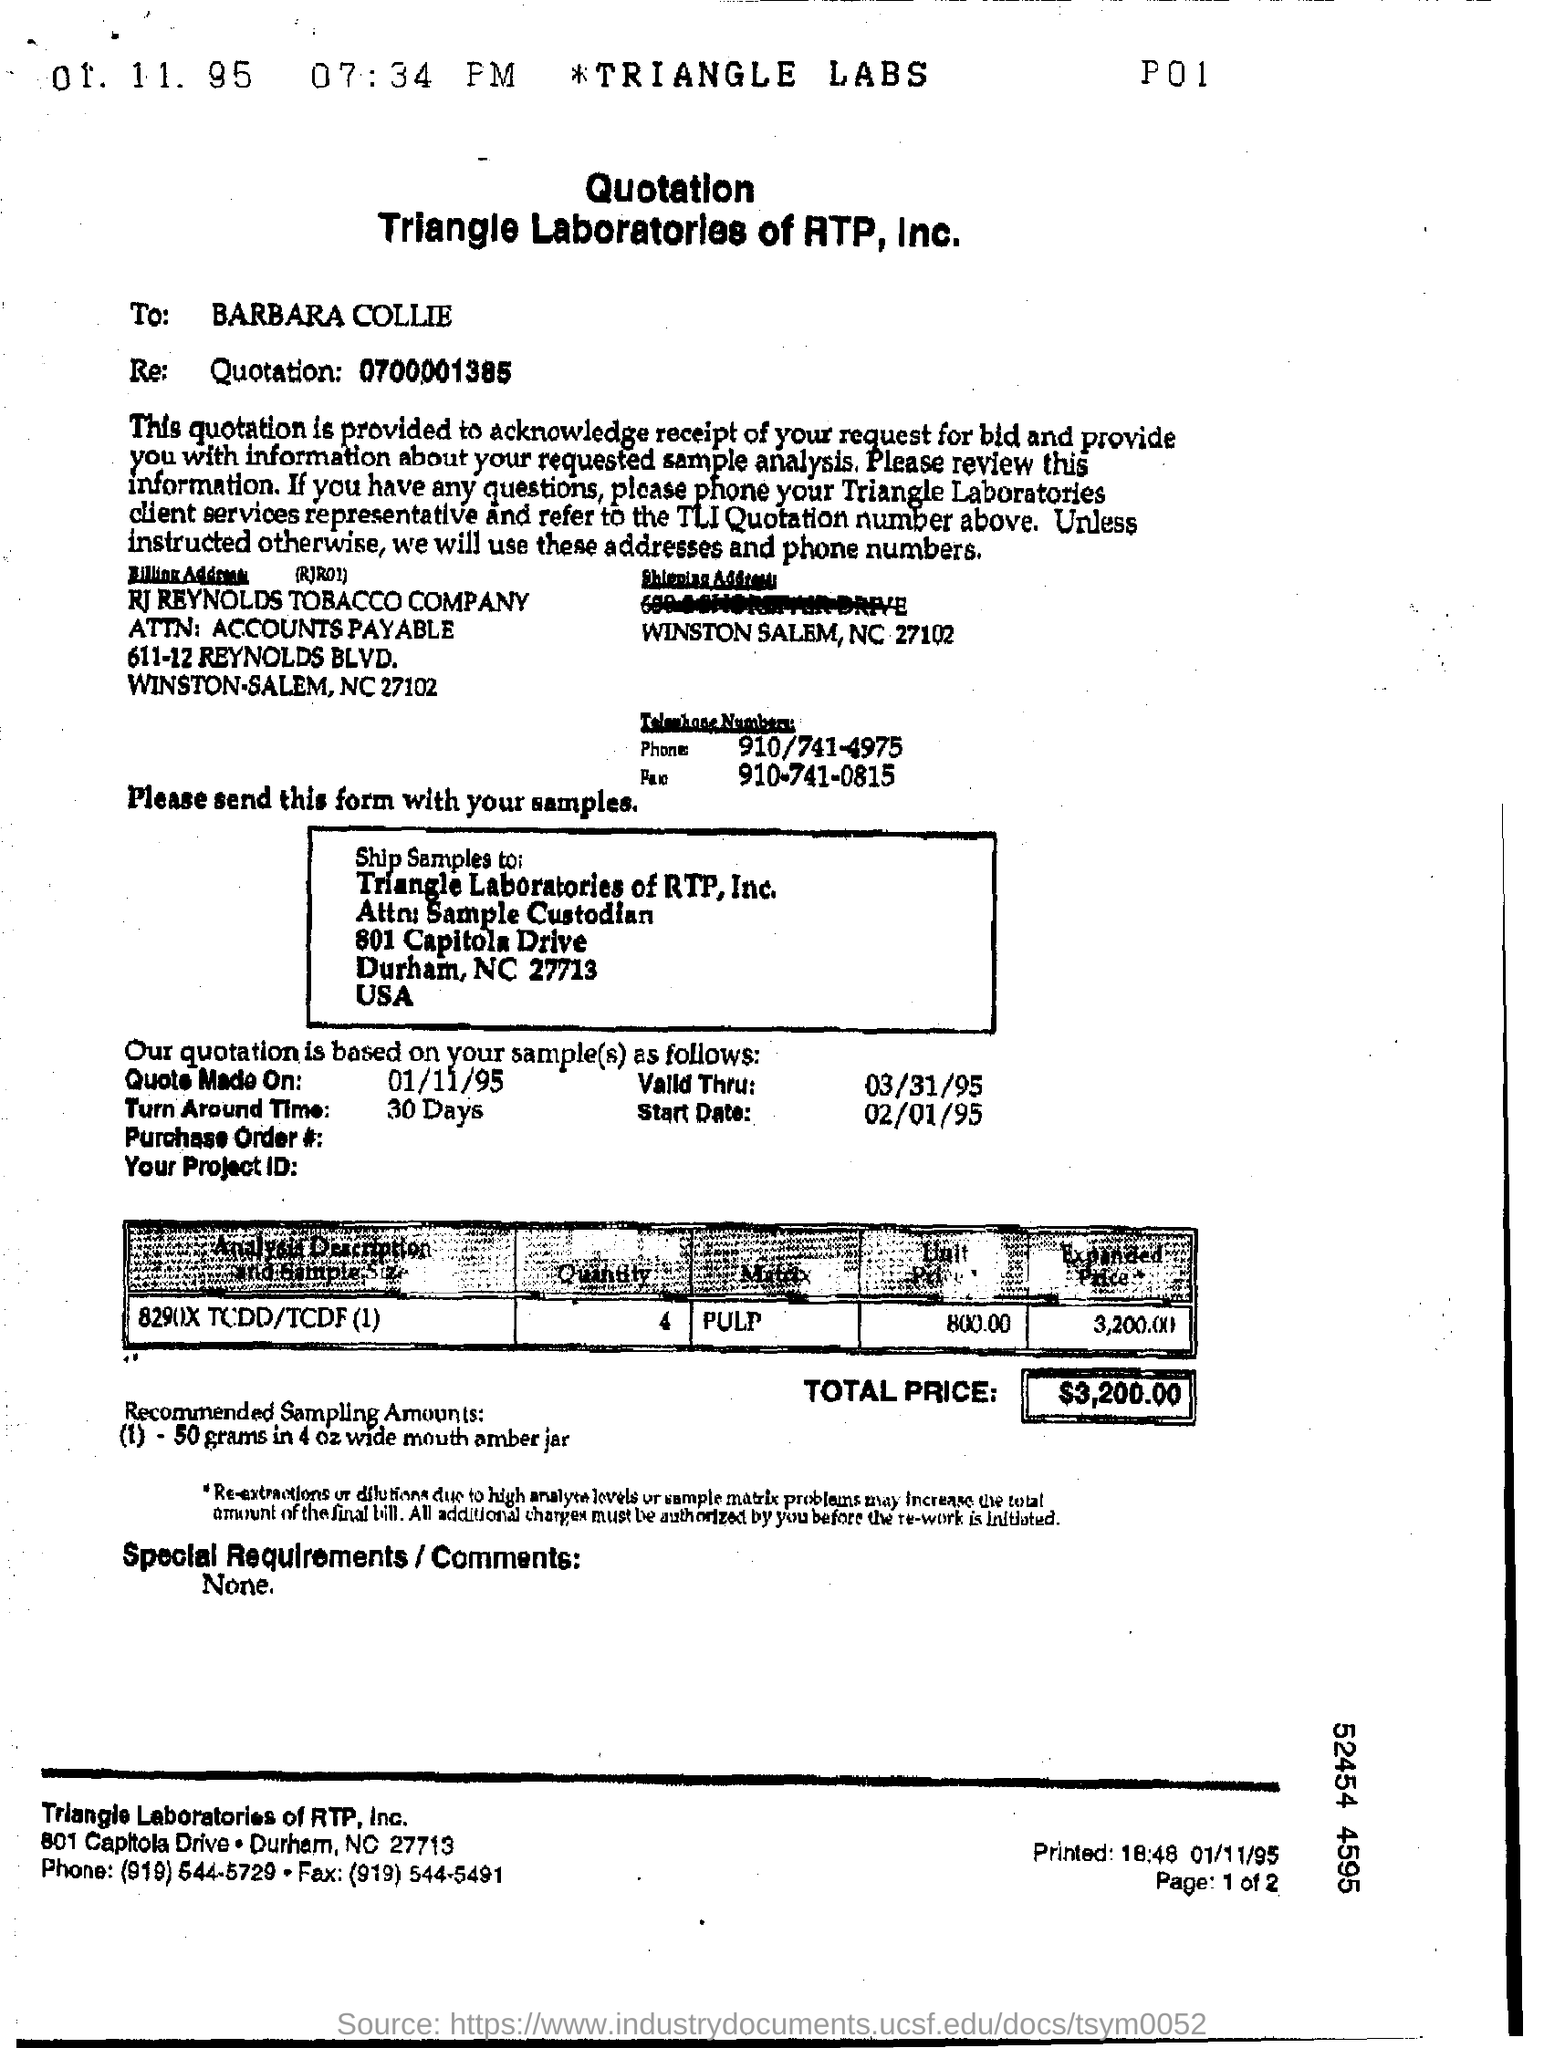To which company, the samples are send?
Provide a succinct answer. Triangle Laboratories of RTP, Inc. To whom, this quotation is addressed?
Keep it short and to the point. Barbara Collie. What is the Turn around time mentioned in the quotation?
Provide a short and direct response. 30 Days. What is the total price in the quotation?
Offer a terse response. $3,200.00. What is the unit price mentioned in the quotation?
Provide a succinct answer. 800.00. When is the quote made on?
Keep it short and to the point. 01/11/95. What is the phone no mentioned in the quotation?
Provide a succinct answer. 910/741-4975. 